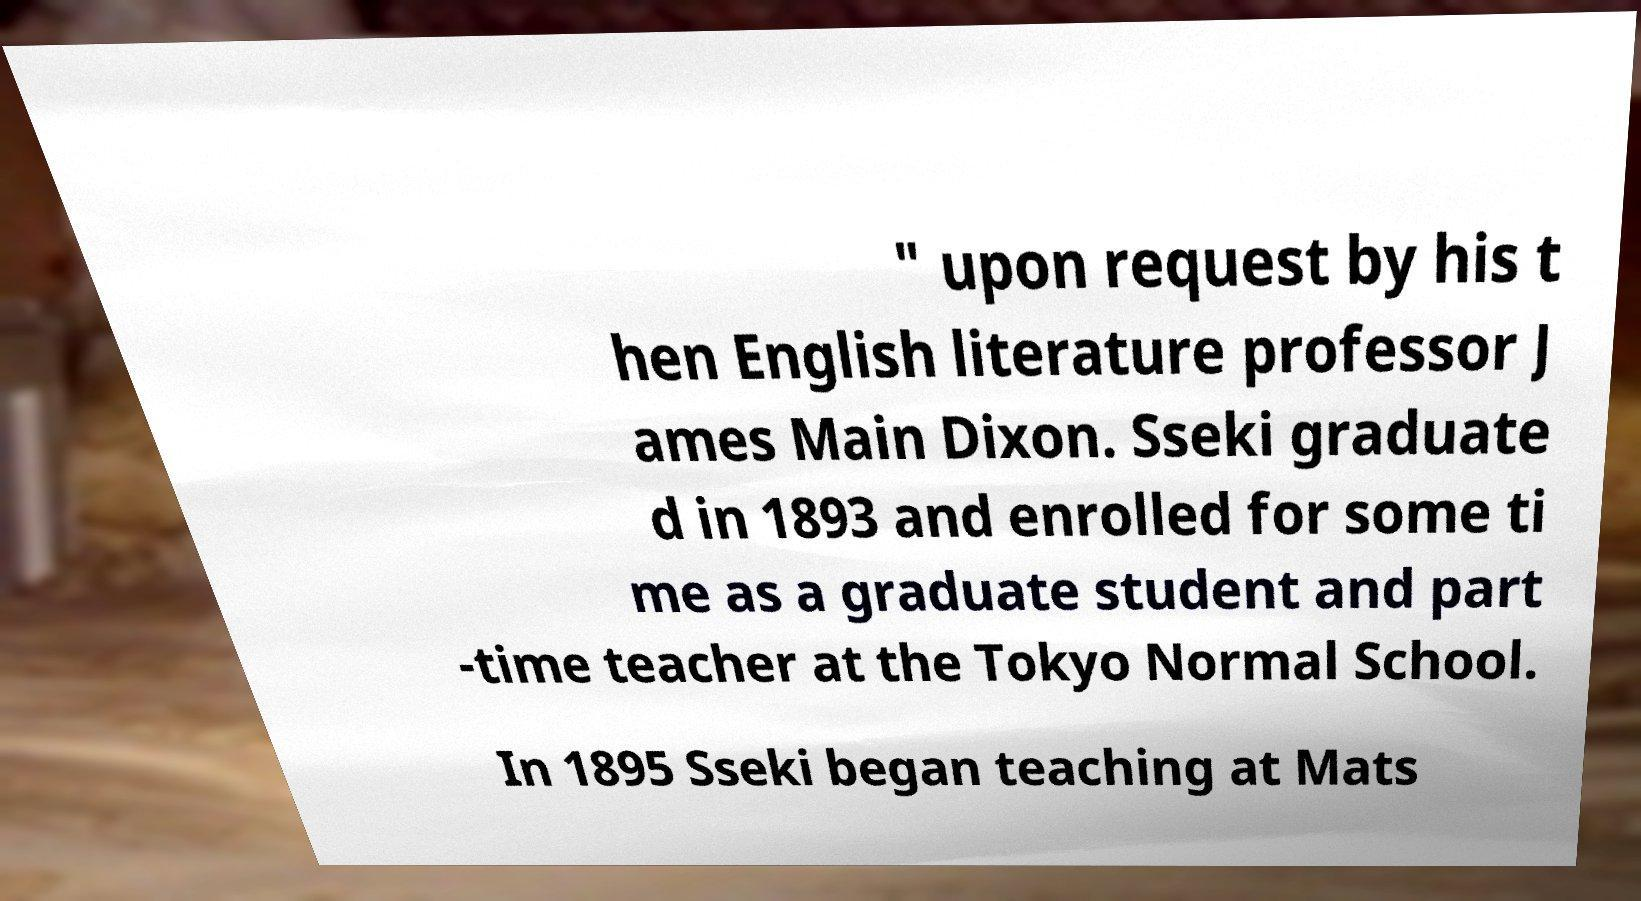Could you assist in decoding the text presented in this image and type it out clearly? " upon request by his t hen English literature professor J ames Main Dixon. Sseki graduate d in 1893 and enrolled for some ti me as a graduate student and part -time teacher at the Tokyo Normal School. In 1895 Sseki began teaching at Mats 